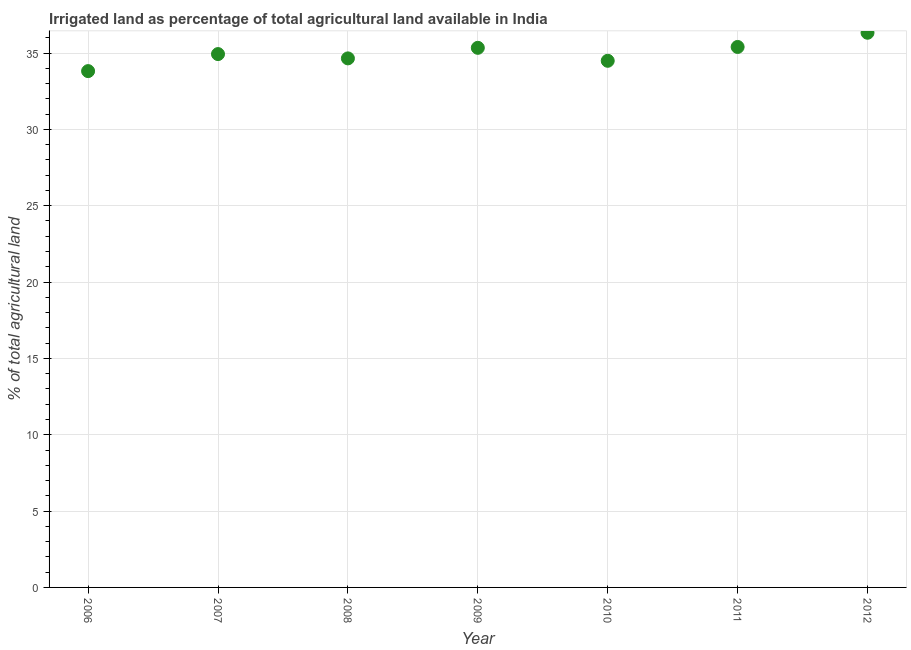What is the percentage of agricultural irrigated land in 2009?
Your response must be concise. 35.34. Across all years, what is the maximum percentage of agricultural irrigated land?
Ensure brevity in your answer.  36.33. Across all years, what is the minimum percentage of agricultural irrigated land?
Provide a succinct answer. 33.82. In which year was the percentage of agricultural irrigated land maximum?
Make the answer very short. 2012. What is the sum of the percentage of agricultural irrigated land?
Your answer should be compact. 244.96. What is the difference between the percentage of agricultural irrigated land in 2010 and 2011?
Offer a very short reply. -0.91. What is the average percentage of agricultural irrigated land per year?
Offer a terse response. 34.99. What is the median percentage of agricultural irrigated land?
Make the answer very short. 34.93. What is the ratio of the percentage of agricultural irrigated land in 2007 to that in 2008?
Offer a very short reply. 1.01. Is the difference between the percentage of agricultural irrigated land in 2009 and 2010 greater than the difference between any two years?
Give a very brief answer. No. What is the difference between the highest and the second highest percentage of agricultural irrigated land?
Your answer should be compact. 0.93. Is the sum of the percentage of agricultural irrigated land in 2010 and 2011 greater than the maximum percentage of agricultural irrigated land across all years?
Keep it short and to the point. Yes. What is the difference between the highest and the lowest percentage of agricultural irrigated land?
Offer a very short reply. 2.51. How many years are there in the graph?
Offer a terse response. 7. What is the difference between two consecutive major ticks on the Y-axis?
Provide a succinct answer. 5. Are the values on the major ticks of Y-axis written in scientific E-notation?
Provide a short and direct response. No. Does the graph contain any zero values?
Make the answer very short. No. What is the title of the graph?
Provide a short and direct response. Irrigated land as percentage of total agricultural land available in India. What is the label or title of the X-axis?
Offer a very short reply. Year. What is the label or title of the Y-axis?
Give a very brief answer. % of total agricultural land. What is the % of total agricultural land in 2006?
Your answer should be very brief. 33.82. What is the % of total agricultural land in 2007?
Give a very brief answer. 34.93. What is the % of total agricultural land in 2008?
Provide a short and direct response. 34.65. What is the % of total agricultural land in 2009?
Provide a succinct answer. 35.34. What is the % of total agricultural land in 2010?
Give a very brief answer. 34.49. What is the % of total agricultural land in 2011?
Ensure brevity in your answer.  35.4. What is the % of total agricultural land in 2012?
Keep it short and to the point. 36.33. What is the difference between the % of total agricultural land in 2006 and 2007?
Offer a very short reply. -1.12. What is the difference between the % of total agricultural land in 2006 and 2008?
Ensure brevity in your answer.  -0.83. What is the difference between the % of total agricultural land in 2006 and 2009?
Offer a terse response. -1.53. What is the difference between the % of total agricultural land in 2006 and 2010?
Make the answer very short. -0.68. What is the difference between the % of total agricultural land in 2006 and 2011?
Your answer should be compact. -1.58. What is the difference between the % of total agricultural land in 2006 and 2012?
Your response must be concise. -2.51. What is the difference between the % of total agricultural land in 2007 and 2008?
Offer a terse response. 0.28. What is the difference between the % of total agricultural land in 2007 and 2009?
Give a very brief answer. -0.41. What is the difference between the % of total agricultural land in 2007 and 2010?
Your response must be concise. 0.44. What is the difference between the % of total agricultural land in 2007 and 2011?
Give a very brief answer. -0.47. What is the difference between the % of total agricultural land in 2007 and 2012?
Provide a short and direct response. -1.4. What is the difference between the % of total agricultural land in 2008 and 2009?
Your answer should be very brief. -0.69. What is the difference between the % of total agricultural land in 2008 and 2010?
Provide a succinct answer. 0.16. What is the difference between the % of total agricultural land in 2008 and 2011?
Your response must be concise. -0.75. What is the difference between the % of total agricultural land in 2008 and 2012?
Make the answer very short. -1.68. What is the difference between the % of total agricultural land in 2009 and 2010?
Offer a terse response. 0.85. What is the difference between the % of total agricultural land in 2009 and 2011?
Your answer should be compact. -0.06. What is the difference between the % of total agricultural land in 2009 and 2012?
Ensure brevity in your answer.  -0.99. What is the difference between the % of total agricultural land in 2010 and 2011?
Your response must be concise. -0.91. What is the difference between the % of total agricultural land in 2010 and 2012?
Your answer should be compact. -1.84. What is the difference between the % of total agricultural land in 2011 and 2012?
Ensure brevity in your answer.  -0.93. What is the ratio of the % of total agricultural land in 2006 to that in 2007?
Provide a succinct answer. 0.97. What is the ratio of the % of total agricultural land in 2006 to that in 2008?
Provide a short and direct response. 0.98. What is the ratio of the % of total agricultural land in 2006 to that in 2011?
Your answer should be very brief. 0.95. What is the ratio of the % of total agricultural land in 2006 to that in 2012?
Provide a succinct answer. 0.93. What is the ratio of the % of total agricultural land in 2007 to that in 2008?
Give a very brief answer. 1.01. What is the ratio of the % of total agricultural land in 2007 to that in 2009?
Make the answer very short. 0.99. What is the ratio of the % of total agricultural land in 2007 to that in 2010?
Offer a terse response. 1.01. What is the ratio of the % of total agricultural land in 2007 to that in 2011?
Keep it short and to the point. 0.99. What is the ratio of the % of total agricultural land in 2007 to that in 2012?
Give a very brief answer. 0.96. What is the ratio of the % of total agricultural land in 2008 to that in 2009?
Give a very brief answer. 0.98. What is the ratio of the % of total agricultural land in 2008 to that in 2010?
Give a very brief answer. 1. What is the ratio of the % of total agricultural land in 2008 to that in 2012?
Your response must be concise. 0.95. What is the ratio of the % of total agricultural land in 2009 to that in 2012?
Offer a very short reply. 0.97. What is the ratio of the % of total agricultural land in 2010 to that in 2011?
Ensure brevity in your answer.  0.97. What is the ratio of the % of total agricultural land in 2010 to that in 2012?
Your answer should be very brief. 0.95. 